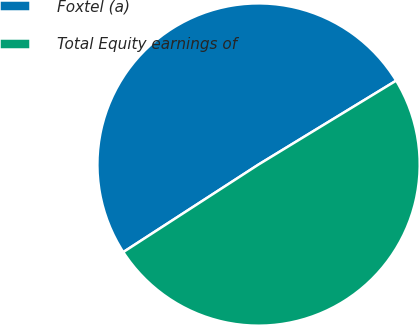<chart> <loc_0><loc_0><loc_500><loc_500><pie_chart><fcel>Foxtel (a)<fcel>Total Equity earnings of<nl><fcel>50.43%<fcel>49.57%<nl></chart> 